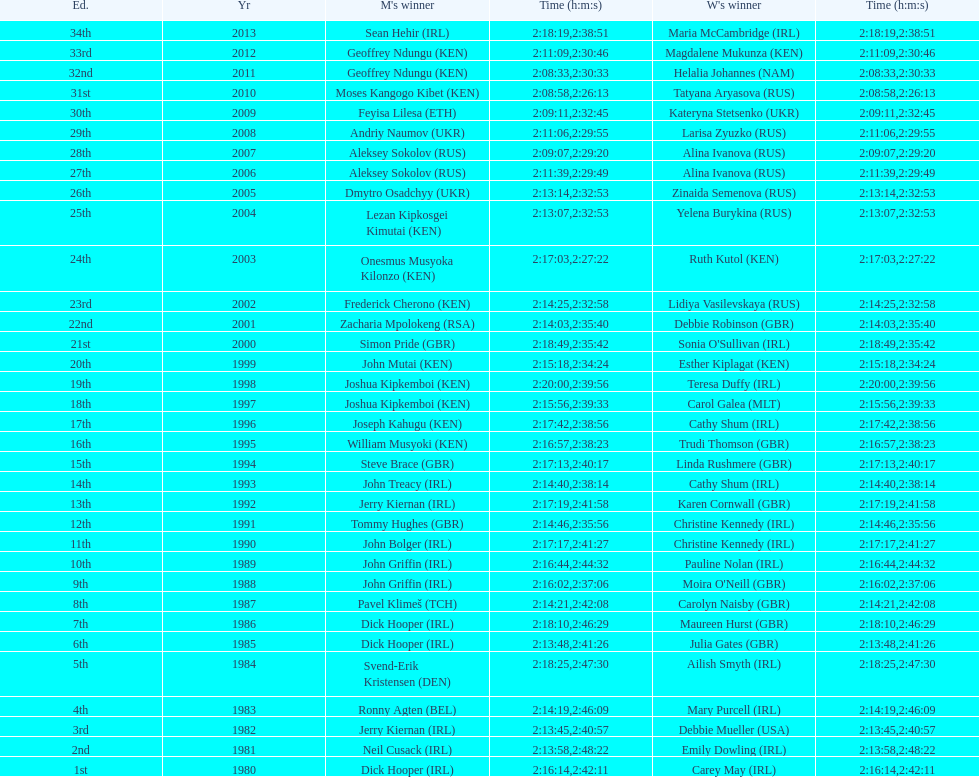In 2009, which competitor finished faster - the male or the female? Male. 